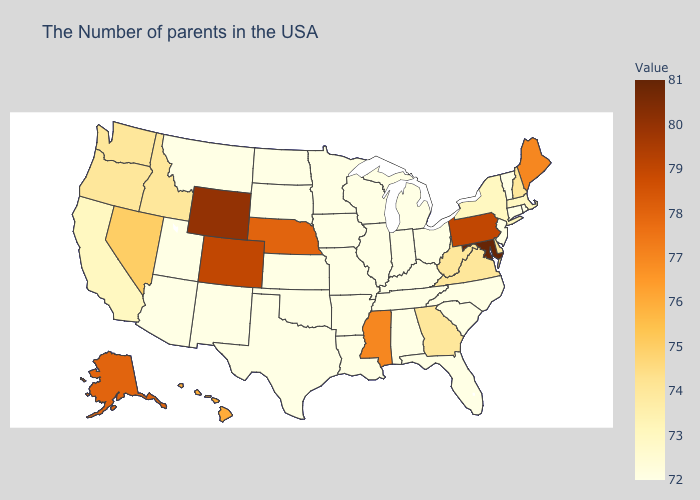Does Missouri have the highest value in the USA?
Quick response, please. No. Which states have the lowest value in the USA?
Be succinct. Rhode Island, Vermont, Connecticut, New Jersey, North Carolina, South Carolina, Ohio, Florida, Michigan, Kentucky, Indiana, Alabama, Tennessee, Wisconsin, Illinois, Louisiana, Missouri, Arkansas, Minnesota, Iowa, Kansas, Oklahoma, Texas, South Dakota, North Dakota, New Mexico, Utah, Montana, Arizona. Which states have the highest value in the USA?
Be succinct. Maryland. Which states hav the highest value in the Northeast?
Quick response, please. Pennsylvania. Which states have the lowest value in the USA?
Be succinct. Rhode Island, Vermont, Connecticut, New Jersey, North Carolina, South Carolina, Ohio, Florida, Michigan, Kentucky, Indiana, Alabama, Tennessee, Wisconsin, Illinois, Louisiana, Missouri, Arkansas, Minnesota, Iowa, Kansas, Oklahoma, Texas, South Dakota, North Dakota, New Mexico, Utah, Montana, Arizona. Among the states that border Georgia , which have the highest value?
Write a very short answer. North Carolina, South Carolina, Florida, Alabama, Tennessee. Does Maryland have the highest value in the South?
Concise answer only. Yes. Among the states that border Nevada , which have the lowest value?
Write a very short answer. Utah, Arizona. 